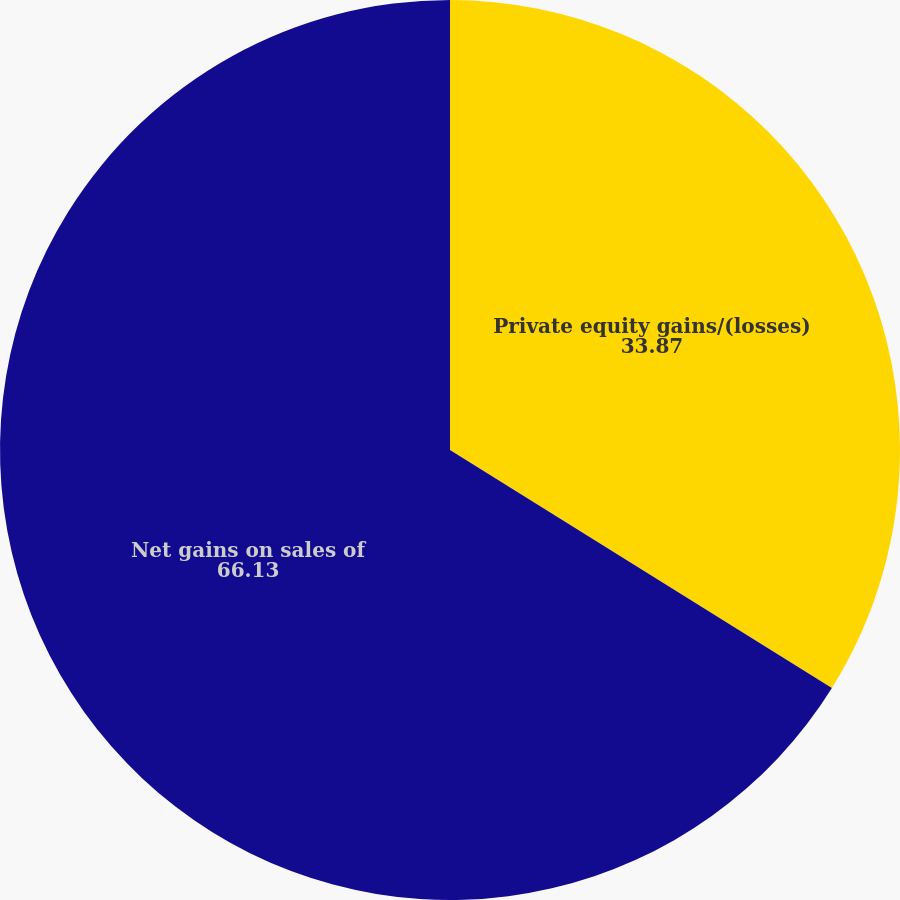<chart> <loc_0><loc_0><loc_500><loc_500><pie_chart><fcel>Private equity gains/(losses)<fcel>Net gains on sales of<nl><fcel>33.87%<fcel>66.13%<nl></chart> 